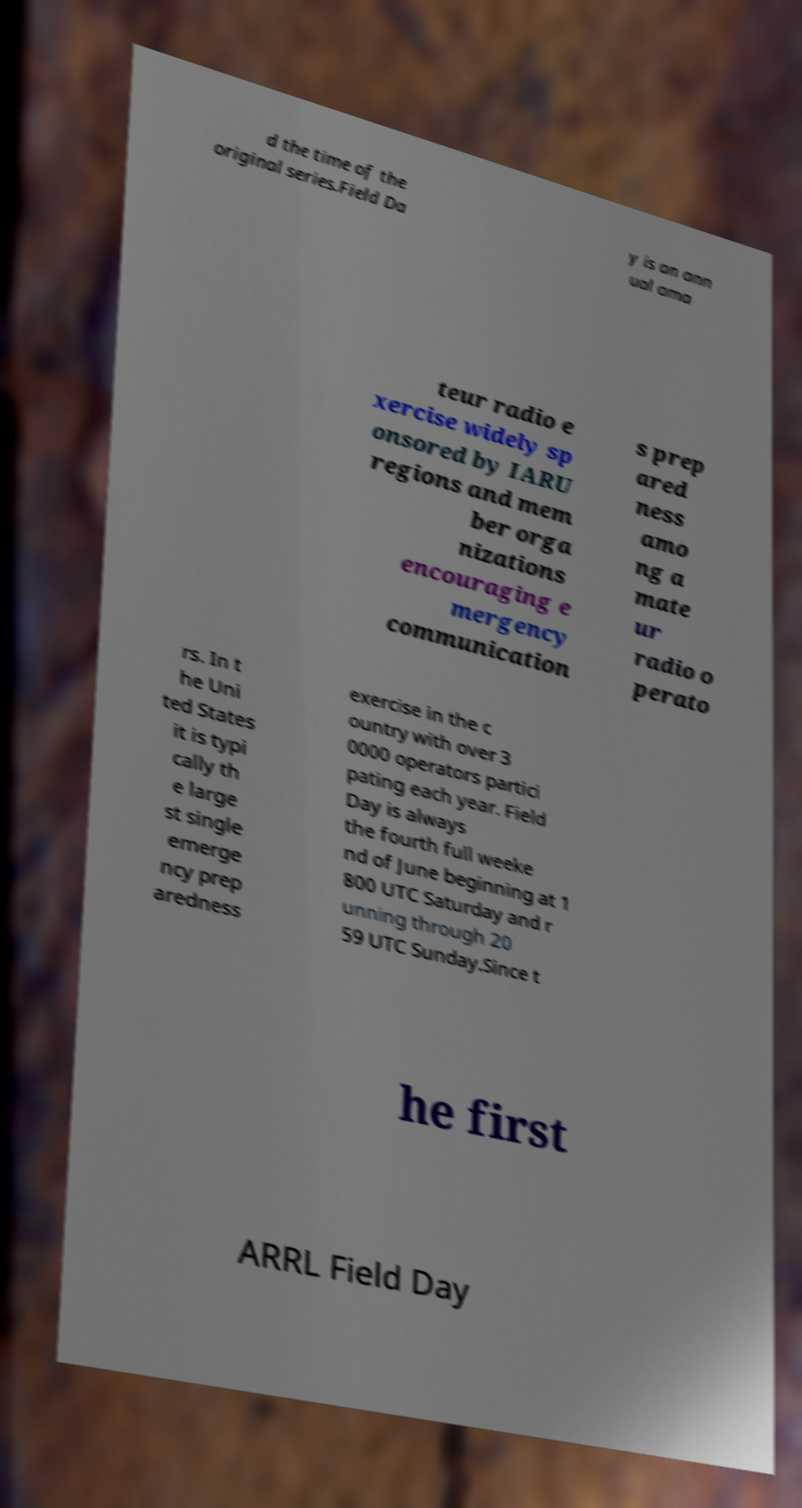For documentation purposes, I need the text within this image transcribed. Could you provide that? d the time of the original series.Field Da y is an ann ual ama teur radio e xercise widely sp onsored by IARU regions and mem ber orga nizations encouraging e mergency communication s prep ared ness amo ng a mate ur radio o perato rs. In t he Uni ted States it is typi cally th e large st single emerge ncy prep aredness exercise in the c ountry with over 3 0000 operators partici pating each year. Field Day is always the fourth full weeke nd of June beginning at 1 800 UTC Saturday and r unning through 20 59 UTC Sunday.Since t he first ARRL Field Day 